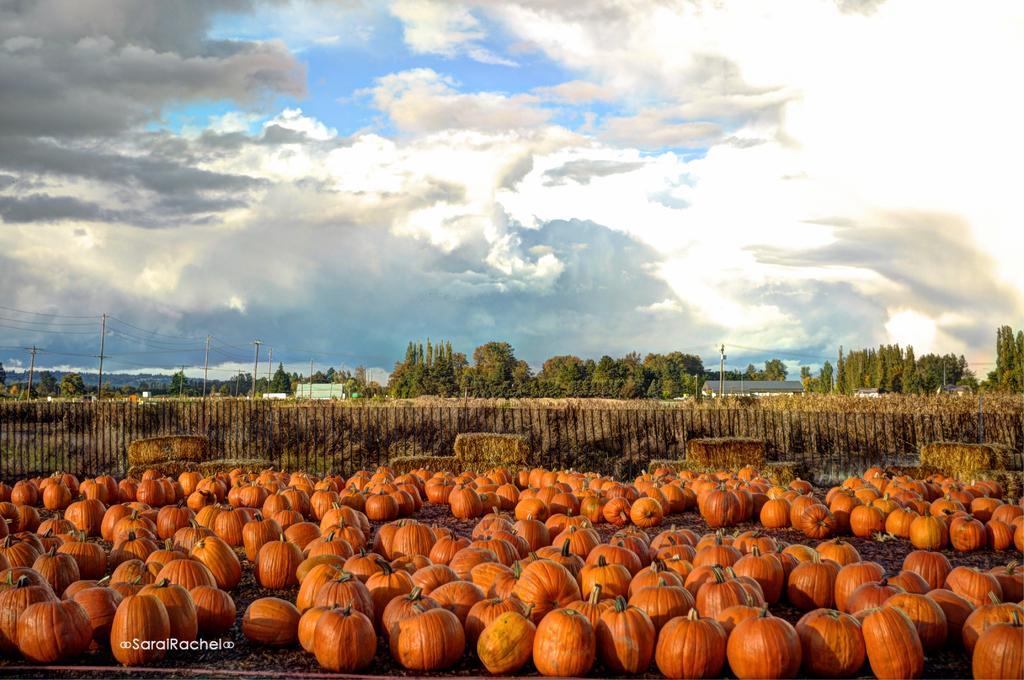Could you give a brief overview of what you see in this image? In the background we can see sky with clouds, trees, current poles with transmission wires. We can see pumpkins on the ground. 